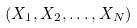<formula> <loc_0><loc_0><loc_500><loc_500>( X _ { 1 } , X _ { 2 } , \dots , X _ { N } )</formula> 